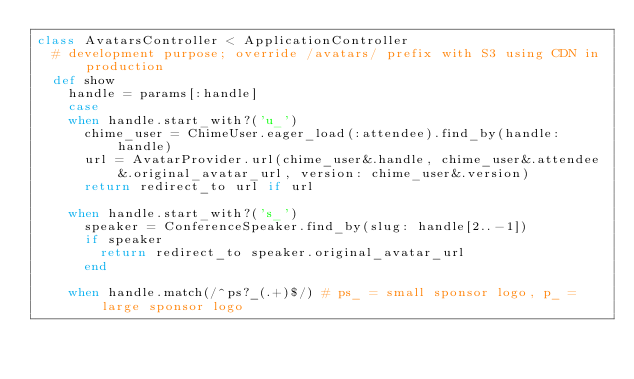Convert code to text. <code><loc_0><loc_0><loc_500><loc_500><_Ruby_>class AvatarsController < ApplicationController
  # development purpose; override /avatars/ prefix with S3 using CDN in production
  def show
    handle = params[:handle]
    case 
    when handle.start_with?('u_')
      chime_user = ChimeUser.eager_load(:attendee).find_by(handle: handle)
      url = AvatarProvider.url(chime_user&.handle, chime_user&.attendee&.original_avatar_url, version: chime_user&.version)
      return redirect_to url if url

    when handle.start_with?('s_')
      speaker = ConferenceSpeaker.find_by(slug: handle[2..-1])
      if speaker
        return redirect_to speaker.original_avatar_url
      end

    when handle.match(/^ps?_(.+)$/) # ps_ = small sponsor logo, p_ = large sponsor logo</code> 